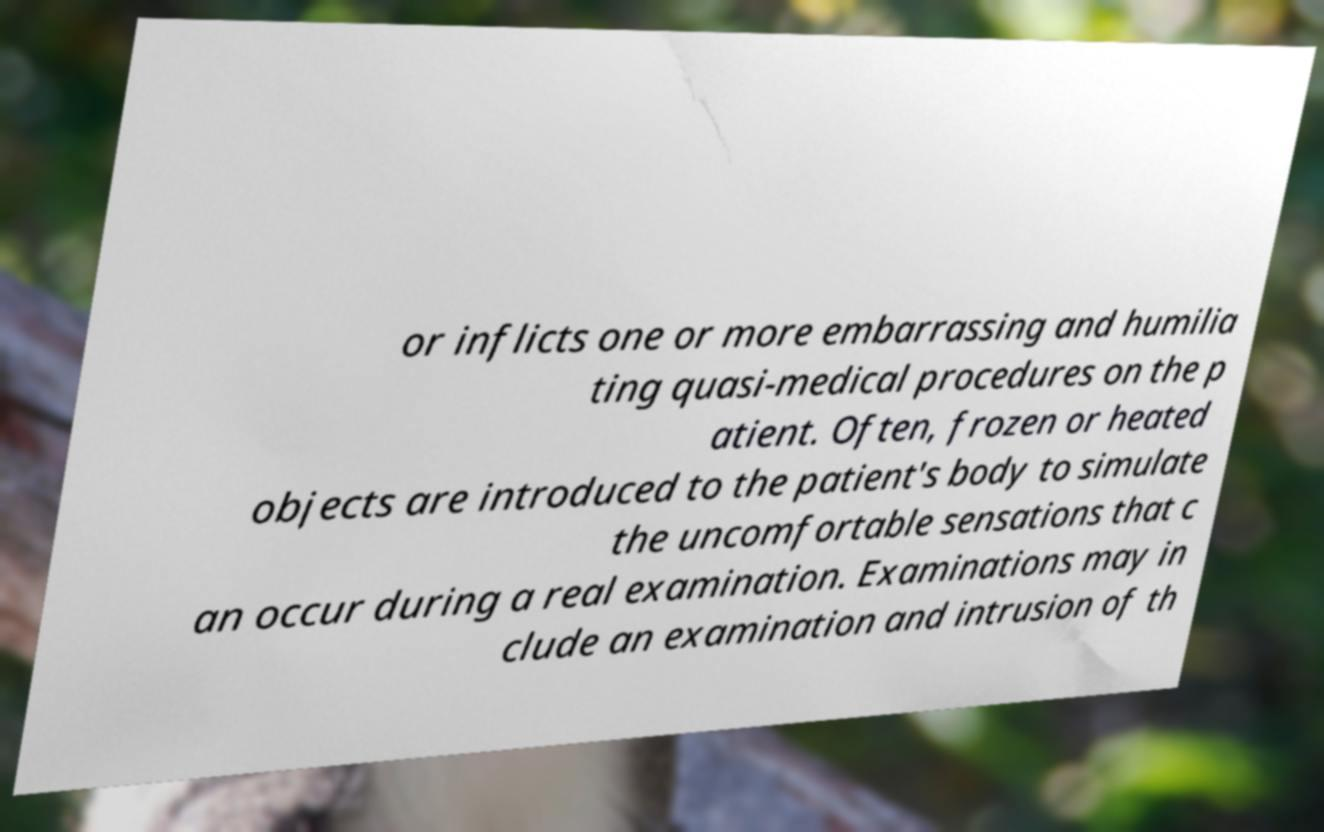Please read and relay the text visible in this image. What does it say? or inflicts one or more embarrassing and humilia ting quasi-medical procedures on the p atient. Often, frozen or heated objects are introduced to the patient's body to simulate the uncomfortable sensations that c an occur during a real examination. Examinations may in clude an examination and intrusion of th 